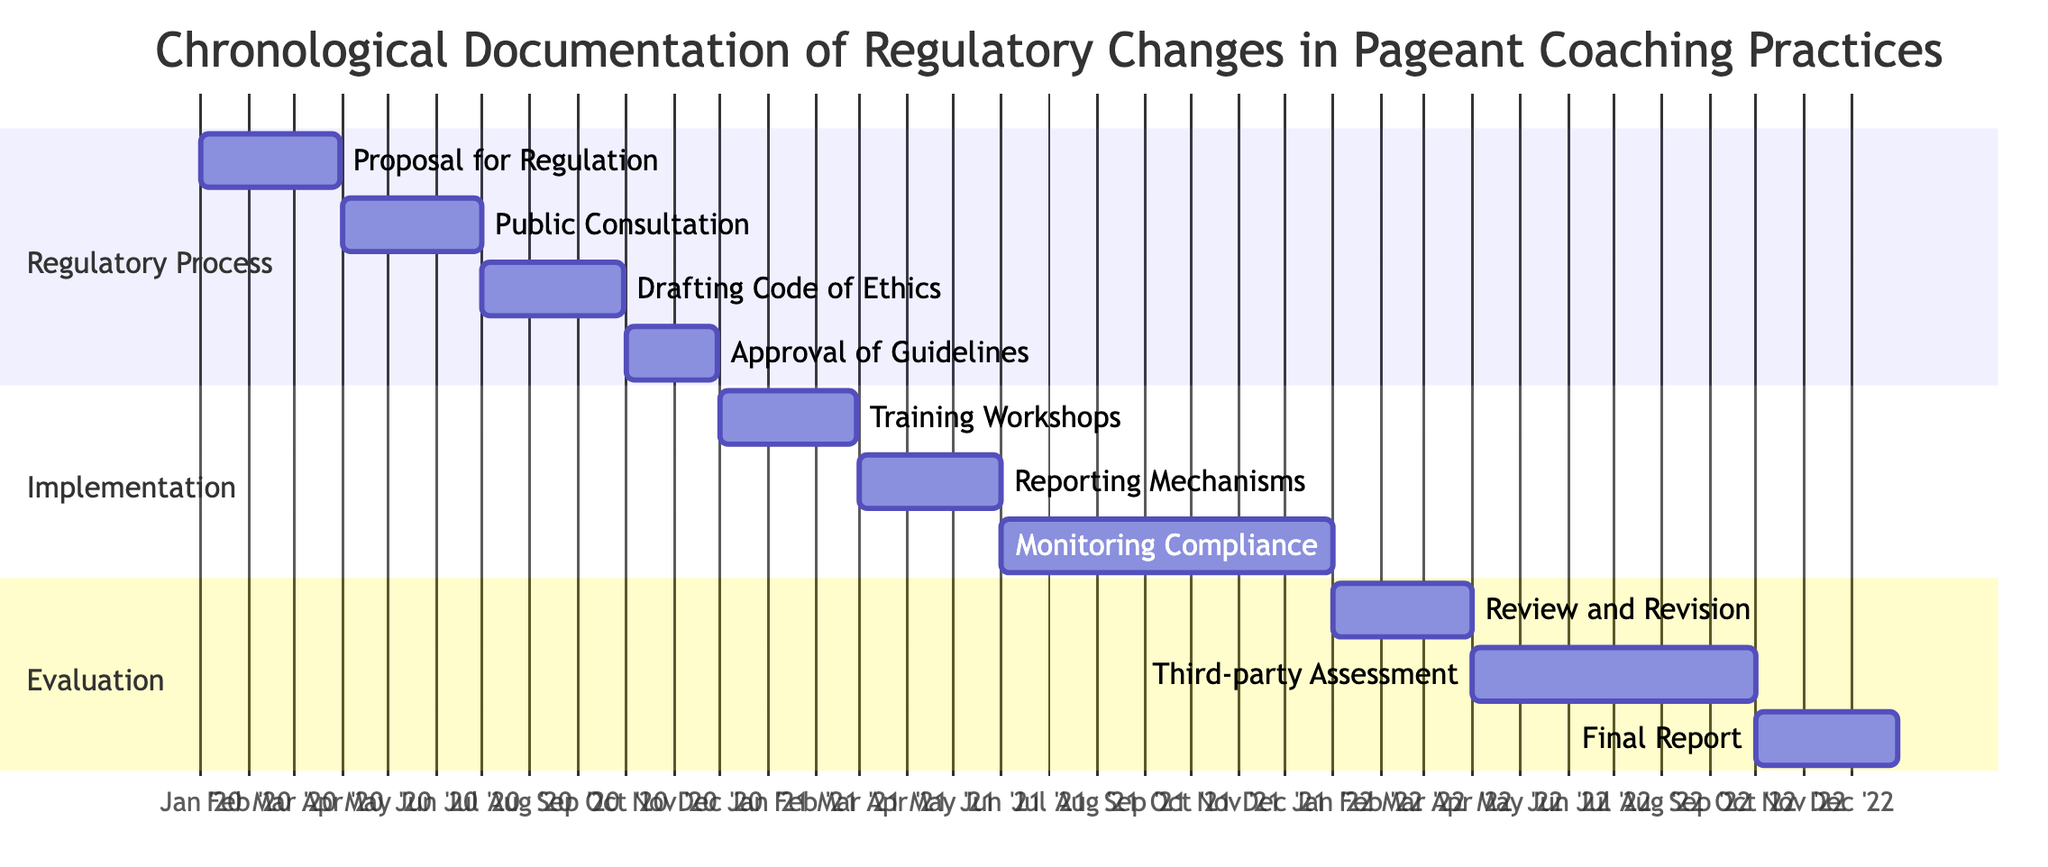What is the overall duration of the regulatory process? The regulatory process begins with the "Proposal for Regulation" on January 1, 2020, and ends with the "Approval of Guidelines" on November 30, 2020. This gives us a total duration of 11 months.
Answer: 11 months What is the start date of the "Training Workshops for Coaches"? The "Training Workshops for Coaches" starts on December 1, 2020, as indicated in the diagram.
Answer: December 1, 2020 How many main sections are there in the Gantt chart? The Gantt chart is divided into three main sections: Regulatory Process, Implementation, and Evaluation. This is discerned from the labelled sections indicated on the chart.
Answer: 3 Which activity is the first to begin in the "Implementation" section? The first activity in the "Implementation" section is "Training Workshops for Coaches," starting on December 1, 2020. This can be identified by checking the start dates within that specific section.
Answer: Training Workshops for Coaches What is the end date of the "Final Report on Regulatory Impact"? The "Final Report on Regulatory Impact" ends on December 31, 2022, which is visible at the end of the timeline for the corresponding section in the chart.
Answer: December 31, 2022 How many activities are there in total in the Gantt chart? By counting the number of individual tasks listed in each section of the Gantt chart, we find that there are a total of 10 activities. This is evidenced by tallying the distinct elements shown in the diagram.
Answer: 10 When was the "Approval of Ethical Guidelines by National Pageant Organization" completed? The "Approval of Ethical Guidelines by National Pageant Organization" was completed by November 30, 2020, which is the end date of that specific activity.
Answer: November 30, 2020 During which month did the "Monitoring Compliance and Gathering Feedback from Competitors" start? The "Monitoring Compliance and Gathering Feedback from Competitors" began on June 1, 2021, as outlined in its start date within the Gantt chart.
Answer: June 1, 2021 What is the duration of the "Third-party Assessment of Coaching Impact"? The "Third-party Assessment of Coaching Impact" lasts for 6 months, from April 1, 2022, to September 30, 2022, calculated from the start date to the end date.
Answer: 6 months 